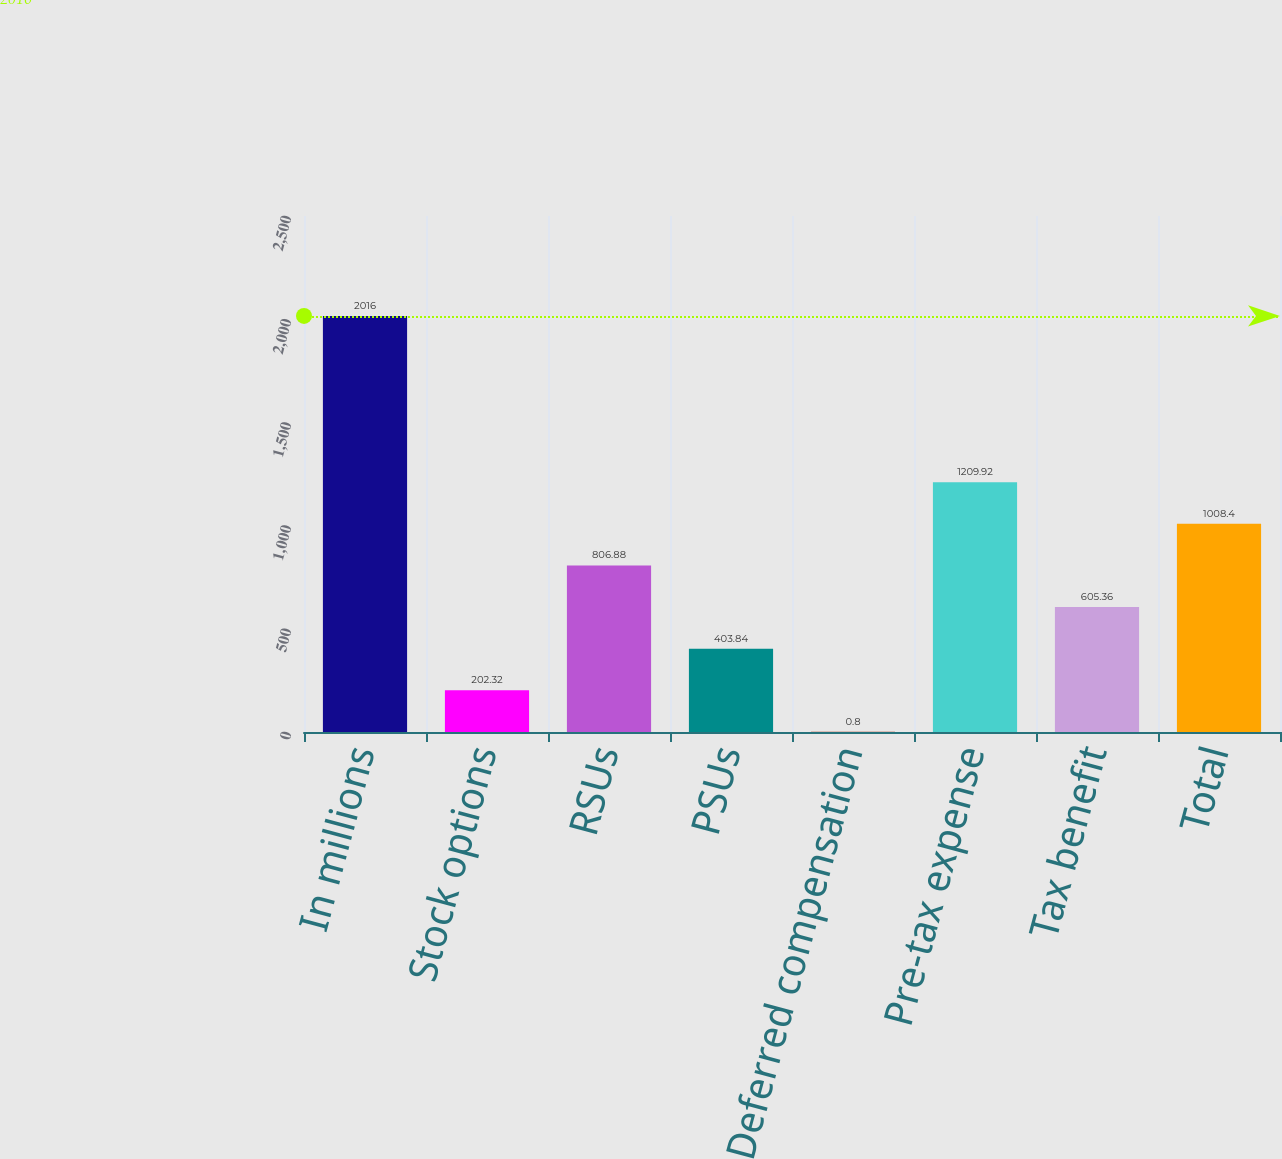<chart> <loc_0><loc_0><loc_500><loc_500><bar_chart><fcel>In millions<fcel>Stock options<fcel>RSUs<fcel>PSUs<fcel>Deferred compensation<fcel>Pre-tax expense<fcel>Tax benefit<fcel>Total<nl><fcel>2016<fcel>202.32<fcel>806.88<fcel>403.84<fcel>0.8<fcel>1209.92<fcel>605.36<fcel>1008.4<nl></chart> 